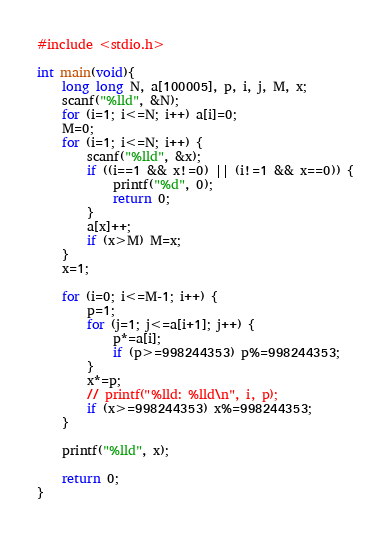Convert code to text. <code><loc_0><loc_0><loc_500><loc_500><_C_>#include <stdio.h>

int main(void){
    long long N, a[100005], p, i, j, M, x;
    scanf("%lld", &N);
    for (i=1; i<=N; i++) a[i]=0;
    M=0;
    for (i=1; i<=N; i++) {
        scanf("%lld", &x);
        if ((i==1 && x!=0) || (i!=1 && x==0)) {
            printf("%d", 0);
            return 0;
        }
        a[x]++;
        if (x>M) M=x;
    }
    x=1;

    for (i=0; i<=M-1; i++) {
        p=1;
        for (j=1; j<=a[i+1]; j++) {
            p*=a[i];
            if (p>=998244353) p%=998244353;
        }
        x*=p;
        // printf("%lld: %lld\n", i, p);
        if (x>=998244353) x%=998244353;
    }

    printf("%lld", x);

    return 0;
}
</code> 